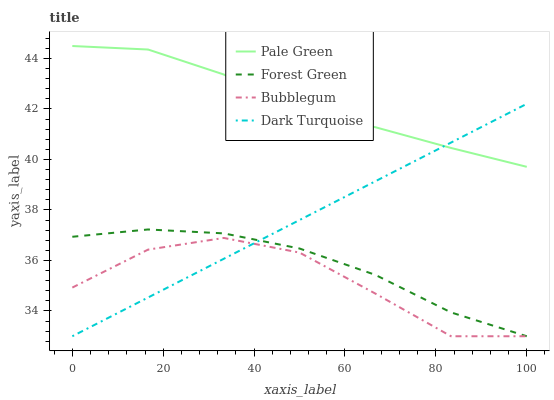Does Bubblegum have the minimum area under the curve?
Answer yes or no. Yes. Does Pale Green have the maximum area under the curve?
Answer yes or no. Yes. Does Forest Green have the minimum area under the curve?
Answer yes or no. No. Does Forest Green have the maximum area under the curve?
Answer yes or no. No. Is Dark Turquoise the smoothest?
Answer yes or no. Yes. Is Bubblegum the roughest?
Answer yes or no. Yes. Is Forest Green the smoothest?
Answer yes or no. No. Is Forest Green the roughest?
Answer yes or no. No. Does Dark Turquoise have the lowest value?
Answer yes or no. Yes. Does Pale Green have the lowest value?
Answer yes or no. No. Does Pale Green have the highest value?
Answer yes or no. Yes. Does Forest Green have the highest value?
Answer yes or no. No. Is Forest Green less than Pale Green?
Answer yes or no. Yes. Is Pale Green greater than Bubblegum?
Answer yes or no. Yes. Does Dark Turquoise intersect Bubblegum?
Answer yes or no. Yes. Is Dark Turquoise less than Bubblegum?
Answer yes or no. No. Is Dark Turquoise greater than Bubblegum?
Answer yes or no. No. Does Forest Green intersect Pale Green?
Answer yes or no. No. 